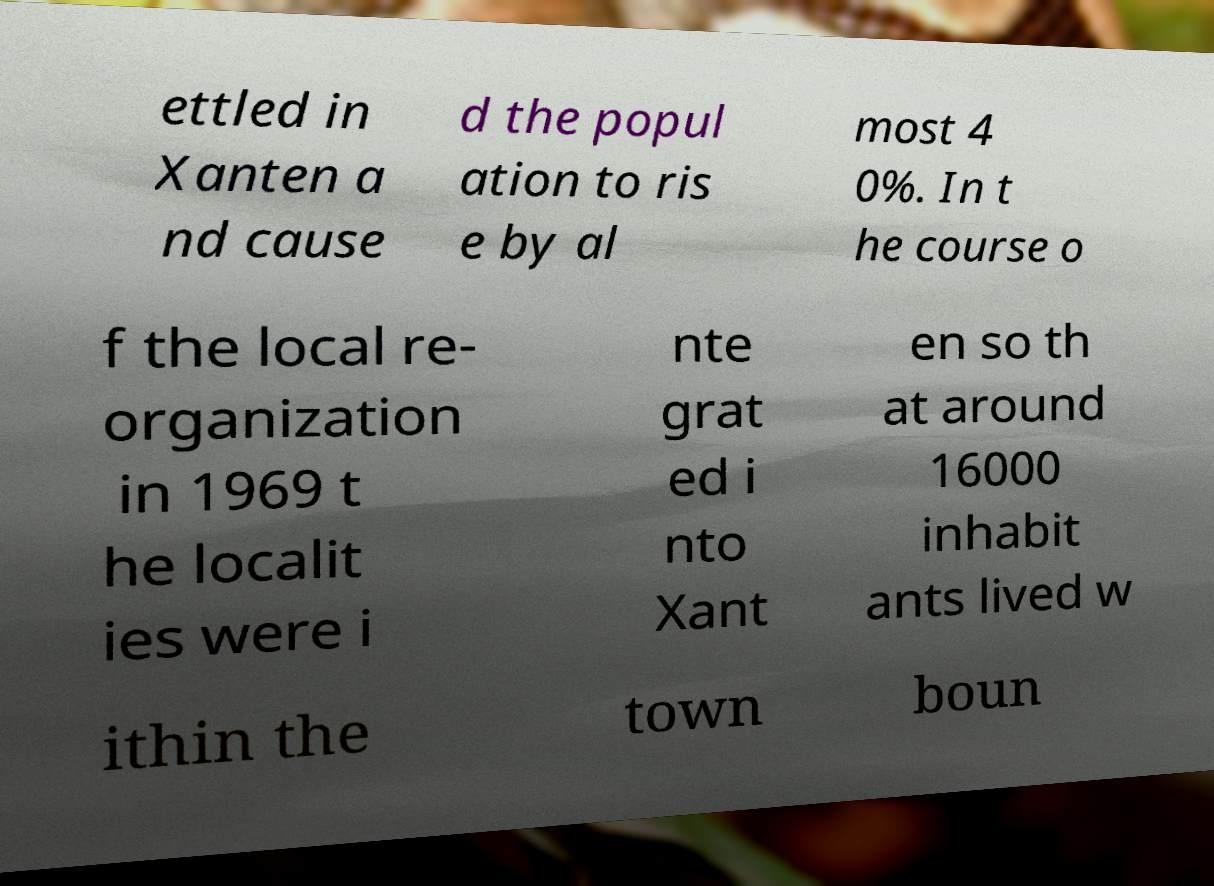For documentation purposes, I need the text within this image transcribed. Could you provide that? ettled in Xanten a nd cause d the popul ation to ris e by al most 4 0%. In t he course o f the local re- organization in 1969 t he localit ies were i nte grat ed i nto Xant en so th at around 16000 inhabit ants lived w ithin the town boun 